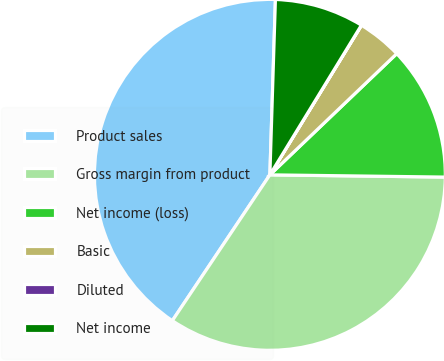Convert chart. <chart><loc_0><loc_0><loc_500><loc_500><pie_chart><fcel>Product sales<fcel>Gross margin from product<fcel>Net income (loss)<fcel>Basic<fcel>Diluted<fcel>Net income<nl><fcel>41.12%<fcel>34.18%<fcel>12.34%<fcel>4.12%<fcel>0.01%<fcel>8.23%<nl></chart> 